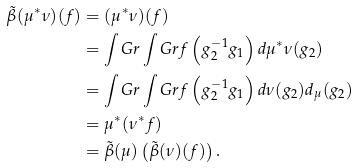<formula> <loc_0><loc_0><loc_500><loc_500>\tilde { \beta } ( \mu ^ { * } \nu ) ( f ) & = ( \mu ^ { * } \nu ) ( f ) \\ & = \int _ { \ } G r \int _ { \ } G r f \left ( g _ { 2 } ^ { - 1 } g _ { 1 } \right ) d { \mu ^ { * } \nu } ( g _ { 2 } ) \\ & = \int _ { \ } G r \int _ { \ } G r f \left ( g _ { 2 } ^ { - 1 } g _ { 1 } \right ) d { \nu } ( g _ { 2 } ) d _ { \mu } ( g _ { 2 } ) \\ & = \mu ^ { * } ( \nu ^ { * } f ) \\ & = \tilde { \beta } ( \mu ) \left ( \tilde { \beta } ( \nu ) ( f ) \right ) .</formula> 